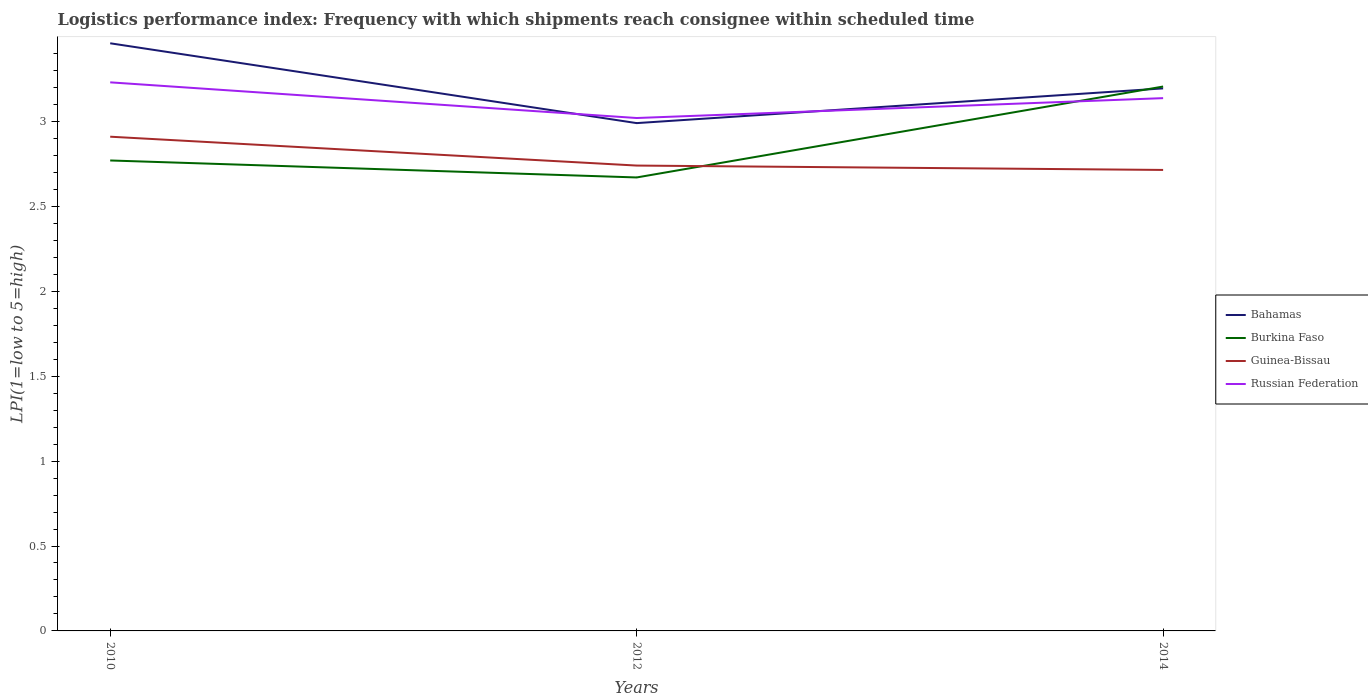How many different coloured lines are there?
Provide a succinct answer. 4. Does the line corresponding to Bahamas intersect with the line corresponding to Guinea-Bissau?
Keep it short and to the point. No. Is the number of lines equal to the number of legend labels?
Offer a terse response. Yes. Across all years, what is the maximum logistics performance index in Bahamas?
Your answer should be very brief. 2.99. In which year was the logistics performance index in Burkina Faso maximum?
Make the answer very short. 2012. What is the total logistics performance index in Russian Federation in the graph?
Provide a short and direct response. 0.09. What is the difference between the highest and the second highest logistics performance index in Guinea-Bissau?
Provide a succinct answer. 0.2. Is the logistics performance index in Guinea-Bissau strictly greater than the logistics performance index in Burkina Faso over the years?
Offer a terse response. No. How many lines are there?
Your response must be concise. 4. How many years are there in the graph?
Give a very brief answer. 3. Are the values on the major ticks of Y-axis written in scientific E-notation?
Offer a terse response. No. Does the graph contain any zero values?
Ensure brevity in your answer.  No. What is the title of the graph?
Your answer should be very brief. Logistics performance index: Frequency with which shipments reach consignee within scheduled time. What is the label or title of the X-axis?
Offer a terse response. Years. What is the label or title of the Y-axis?
Your answer should be very brief. LPI(1=low to 5=high). What is the LPI(1=low to 5=high) in Bahamas in 2010?
Make the answer very short. 3.46. What is the LPI(1=low to 5=high) of Burkina Faso in 2010?
Your answer should be compact. 2.77. What is the LPI(1=low to 5=high) of Guinea-Bissau in 2010?
Ensure brevity in your answer.  2.91. What is the LPI(1=low to 5=high) of Russian Federation in 2010?
Offer a very short reply. 3.23. What is the LPI(1=low to 5=high) of Bahamas in 2012?
Keep it short and to the point. 2.99. What is the LPI(1=low to 5=high) in Burkina Faso in 2012?
Offer a terse response. 2.67. What is the LPI(1=low to 5=high) of Guinea-Bissau in 2012?
Offer a terse response. 2.74. What is the LPI(1=low to 5=high) of Russian Federation in 2012?
Offer a very short reply. 3.02. What is the LPI(1=low to 5=high) of Bahamas in 2014?
Provide a short and direct response. 3.19. What is the LPI(1=low to 5=high) in Burkina Faso in 2014?
Offer a very short reply. 3.21. What is the LPI(1=low to 5=high) of Guinea-Bissau in 2014?
Provide a succinct answer. 2.71. What is the LPI(1=low to 5=high) in Russian Federation in 2014?
Your response must be concise. 3.14. Across all years, what is the maximum LPI(1=low to 5=high) of Bahamas?
Your response must be concise. 3.46. Across all years, what is the maximum LPI(1=low to 5=high) in Burkina Faso?
Provide a short and direct response. 3.21. Across all years, what is the maximum LPI(1=low to 5=high) of Guinea-Bissau?
Offer a terse response. 2.91. Across all years, what is the maximum LPI(1=low to 5=high) of Russian Federation?
Offer a very short reply. 3.23. Across all years, what is the minimum LPI(1=low to 5=high) in Bahamas?
Provide a short and direct response. 2.99. Across all years, what is the minimum LPI(1=low to 5=high) of Burkina Faso?
Give a very brief answer. 2.67. Across all years, what is the minimum LPI(1=low to 5=high) in Guinea-Bissau?
Your response must be concise. 2.71. Across all years, what is the minimum LPI(1=low to 5=high) of Russian Federation?
Your response must be concise. 3.02. What is the total LPI(1=low to 5=high) of Bahamas in the graph?
Give a very brief answer. 9.64. What is the total LPI(1=low to 5=high) of Burkina Faso in the graph?
Give a very brief answer. 8.65. What is the total LPI(1=low to 5=high) of Guinea-Bissau in the graph?
Offer a very short reply. 8.36. What is the total LPI(1=low to 5=high) in Russian Federation in the graph?
Your response must be concise. 9.39. What is the difference between the LPI(1=low to 5=high) of Bahamas in 2010 and that in 2012?
Your answer should be very brief. 0.47. What is the difference between the LPI(1=low to 5=high) in Guinea-Bissau in 2010 and that in 2012?
Provide a succinct answer. 0.17. What is the difference between the LPI(1=low to 5=high) of Russian Federation in 2010 and that in 2012?
Offer a very short reply. 0.21. What is the difference between the LPI(1=low to 5=high) of Bahamas in 2010 and that in 2014?
Provide a short and direct response. 0.27. What is the difference between the LPI(1=low to 5=high) of Burkina Faso in 2010 and that in 2014?
Give a very brief answer. -0.44. What is the difference between the LPI(1=low to 5=high) of Guinea-Bissau in 2010 and that in 2014?
Your response must be concise. 0.2. What is the difference between the LPI(1=low to 5=high) of Russian Federation in 2010 and that in 2014?
Your answer should be compact. 0.09. What is the difference between the LPI(1=low to 5=high) of Bahamas in 2012 and that in 2014?
Keep it short and to the point. -0.2. What is the difference between the LPI(1=low to 5=high) in Burkina Faso in 2012 and that in 2014?
Provide a short and direct response. -0.54. What is the difference between the LPI(1=low to 5=high) of Guinea-Bissau in 2012 and that in 2014?
Ensure brevity in your answer.  0.03. What is the difference between the LPI(1=low to 5=high) of Russian Federation in 2012 and that in 2014?
Provide a short and direct response. -0.12. What is the difference between the LPI(1=low to 5=high) in Bahamas in 2010 and the LPI(1=low to 5=high) in Burkina Faso in 2012?
Make the answer very short. 0.79. What is the difference between the LPI(1=low to 5=high) in Bahamas in 2010 and the LPI(1=low to 5=high) in Guinea-Bissau in 2012?
Your answer should be compact. 0.72. What is the difference between the LPI(1=low to 5=high) in Bahamas in 2010 and the LPI(1=low to 5=high) in Russian Federation in 2012?
Make the answer very short. 0.44. What is the difference between the LPI(1=low to 5=high) in Burkina Faso in 2010 and the LPI(1=low to 5=high) in Guinea-Bissau in 2012?
Ensure brevity in your answer.  0.03. What is the difference between the LPI(1=low to 5=high) of Burkina Faso in 2010 and the LPI(1=low to 5=high) of Russian Federation in 2012?
Keep it short and to the point. -0.25. What is the difference between the LPI(1=low to 5=high) in Guinea-Bissau in 2010 and the LPI(1=low to 5=high) in Russian Federation in 2012?
Make the answer very short. -0.11. What is the difference between the LPI(1=low to 5=high) in Bahamas in 2010 and the LPI(1=low to 5=high) in Burkina Faso in 2014?
Make the answer very short. 0.25. What is the difference between the LPI(1=low to 5=high) in Bahamas in 2010 and the LPI(1=low to 5=high) in Guinea-Bissau in 2014?
Offer a terse response. 0.75. What is the difference between the LPI(1=low to 5=high) in Bahamas in 2010 and the LPI(1=low to 5=high) in Russian Federation in 2014?
Offer a terse response. 0.32. What is the difference between the LPI(1=low to 5=high) in Burkina Faso in 2010 and the LPI(1=low to 5=high) in Guinea-Bissau in 2014?
Give a very brief answer. 0.06. What is the difference between the LPI(1=low to 5=high) in Burkina Faso in 2010 and the LPI(1=low to 5=high) in Russian Federation in 2014?
Provide a short and direct response. -0.37. What is the difference between the LPI(1=low to 5=high) in Guinea-Bissau in 2010 and the LPI(1=low to 5=high) in Russian Federation in 2014?
Provide a short and direct response. -0.23. What is the difference between the LPI(1=low to 5=high) of Bahamas in 2012 and the LPI(1=low to 5=high) of Burkina Faso in 2014?
Give a very brief answer. -0.22. What is the difference between the LPI(1=low to 5=high) in Bahamas in 2012 and the LPI(1=low to 5=high) in Guinea-Bissau in 2014?
Offer a very short reply. 0.28. What is the difference between the LPI(1=low to 5=high) in Bahamas in 2012 and the LPI(1=low to 5=high) in Russian Federation in 2014?
Your answer should be compact. -0.15. What is the difference between the LPI(1=low to 5=high) in Burkina Faso in 2012 and the LPI(1=low to 5=high) in Guinea-Bissau in 2014?
Keep it short and to the point. -0.04. What is the difference between the LPI(1=low to 5=high) of Burkina Faso in 2012 and the LPI(1=low to 5=high) of Russian Federation in 2014?
Give a very brief answer. -0.47. What is the difference between the LPI(1=low to 5=high) in Guinea-Bissau in 2012 and the LPI(1=low to 5=high) in Russian Federation in 2014?
Provide a short and direct response. -0.4. What is the average LPI(1=low to 5=high) in Bahamas per year?
Your answer should be very brief. 3.21. What is the average LPI(1=low to 5=high) in Burkina Faso per year?
Give a very brief answer. 2.88. What is the average LPI(1=low to 5=high) of Guinea-Bissau per year?
Offer a terse response. 2.79. What is the average LPI(1=low to 5=high) in Russian Federation per year?
Keep it short and to the point. 3.13. In the year 2010, what is the difference between the LPI(1=low to 5=high) in Bahamas and LPI(1=low to 5=high) in Burkina Faso?
Give a very brief answer. 0.69. In the year 2010, what is the difference between the LPI(1=low to 5=high) in Bahamas and LPI(1=low to 5=high) in Guinea-Bissau?
Provide a succinct answer. 0.55. In the year 2010, what is the difference between the LPI(1=low to 5=high) in Bahamas and LPI(1=low to 5=high) in Russian Federation?
Your answer should be very brief. 0.23. In the year 2010, what is the difference between the LPI(1=low to 5=high) of Burkina Faso and LPI(1=low to 5=high) of Guinea-Bissau?
Your answer should be compact. -0.14. In the year 2010, what is the difference between the LPI(1=low to 5=high) of Burkina Faso and LPI(1=low to 5=high) of Russian Federation?
Offer a very short reply. -0.46. In the year 2010, what is the difference between the LPI(1=low to 5=high) in Guinea-Bissau and LPI(1=low to 5=high) in Russian Federation?
Make the answer very short. -0.32. In the year 2012, what is the difference between the LPI(1=low to 5=high) of Bahamas and LPI(1=low to 5=high) of Burkina Faso?
Keep it short and to the point. 0.32. In the year 2012, what is the difference between the LPI(1=low to 5=high) in Bahamas and LPI(1=low to 5=high) in Guinea-Bissau?
Make the answer very short. 0.25. In the year 2012, what is the difference between the LPI(1=low to 5=high) in Bahamas and LPI(1=low to 5=high) in Russian Federation?
Give a very brief answer. -0.03. In the year 2012, what is the difference between the LPI(1=low to 5=high) in Burkina Faso and LPI(1=low to 5=high) in Guinea-Bissau?
Your response must be concise. -0.07. In the year 2012, what is the difference between the LPI(1=low to 5=high) of Burkina Faso and LPI(1=low to 5=high) of Russian Federation?
Offer a very short reply. -0.35. In the year 2012, what is the difference between the LPI(1=low to 5=high) of Guinea-Bissau and LPI(1=low to 5=high) of Russian Federation?
Offer a terse response. -0.28. In the year 2014, what is the difference between the LPI(1=low to 5=high) of Bahamas and LPI(1=low to 5=high) of Burkina Faso?
Keep it short and to the point. -0.01. In the year 2014, what is the difference between the LPI(1=low to 5=high) of Bahamas and LPI(1=low to 5=high) of Guinea-Bissau?
Offer a terse response. 0.48. In the year 2014, what is the difference between the LPI(1=low to 5=high) in Bahamas and LPI(1=low to 5=high) in Russian Federation?
Make the answer very short. 0.06. In the year 2014, what is the difference between the LPI(1=low to 5=high) in Burkina Faso and LPI(1=low to 5=high) in Guinea-Bissau?
Your answer should be very brief. 0.49. In the year 2014, what is the difference between the LPI(1=low to 5=high) in Burkina Faso and LPI(1=low to 5=high) in Russian Federation?
Provide a short and direct response. 0.07. In the year 2014, what is the difference between the LPI(1=low to 5=high) of Guinea-Bissau and LPI(1=low to 5=high) of Russian Federation?
Offer a terse response. -0.42. What is the ratio of the LPI(1=low to 5=high) of Bahamas in 2010 to that in 2012?
Give a very brief answer. 1.16. What is the ratio of the LPI(1=low to 5=high) in Burkina Faso in 2010 to that in 2012?
Offer a terse response. 1.04. What is the ratio of the LPI(1=low to 5=high) in Guinea-Bissau in 2010 to that in 2012?
Give a very brief answer. 1.06. What is the ratio of the LPI(1=low to 5=high) in Russian Federation in 2010 to that in 2012?
Give a very brief answer. 1.07. What is the ratio of the LPI(1=low to 5=high) of Bahamas in 2010 to that in 2014?
Your answer should be compact. 1.08. What is the ratio of the LPI(1=low to 5=high) of Burkina Faso in 2010 to that in 2014?
Provide a short and direct response. 0.86. What is the ratio of the LPI(1=low to 5=high) of Guinea-Bissau in 2010 to that in 2014?
Your answer should be compact. 1.07. What is the ratio of the LPI(1=low to 5=high) of Russian Federation in 2010 to that in 2014?
Ensure brevity in your answer.  1.03. What is the ratio of the LPI(1=low to 5=high) of Bahamas in 2012 to that in 2014?
Your answer should be compact. 0.94. What is the ratio of the LPI(1=low to 5=high) in Burkina Faso in 2012 to that in 2014?
Ensure brevity in your answer.  0.83. What is the ratio of the LPI(1=low to 5=high) of Guinea-Bissau in 2012 to that in 2014?
Your response must be concise. 1.01. What is the ratio of the LPI(1=low to 5=high) in Russian Federation in 2012 to that in 2014?
Provide a succinct answer. 0.96. What is the difference between the highest and the second highest LPI(1=low to 5=high) of Bahamas?
Offer a terse response. 0.27. What is the difference between the highest and the second highest LPI(1=low to 5=high) in Burkina Faso?
Your answer should be very brief. 0.44. What is the difference between the highest and the second highest LPI(1=low to 5=high) in Guinea-Bissau?
Provide a succinct answer. 0.17. What is the difference between the highest and the second highest LPI(1=low to 5=high) in Russian Federation?
Ensure brevity in your answer.  0.09. What is the difference between the highest and the lowest LPI(1=low to 5=high) in Bahamas?
Your response must be concise. 0.47. What is the difference between the highest and the lowest LPI(1=low to 5=high) in Burkina Faso?
Your answer should be very brief. 0.54. What is the difference between the highest and the lowest LPI(1=low to 5=high) in Guinea-Bissau?
Offer a terse response. 0.2. What is the difference between the highest and the lowest LPI(1=low to 5=high) of Russian Federation?
Offer a very short reply. 0.21. 